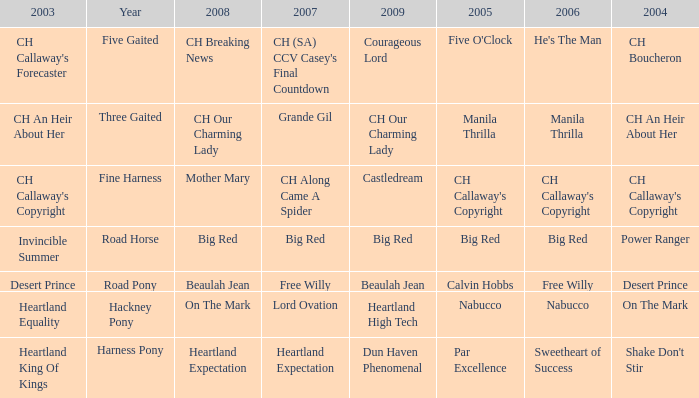What year is the 2007 big red? Road Horse. Give me the full table as a dictionary. {'header': ['2003', 'Year', '2008', '2007', '2009', '2005', '2006', '2004'], 'rows': [["CH Callaway's Forecaster", 'Five Gaited', 'CH Breaking News', "CH (SA) CCV Casey's Final Countdown", 'Courageous Lord', "Five O'Clock", "He's The Man", 'CH Boucheron'], ['CH An Heir About Her', 'Three Gaited', 'CH Our Charming Lady', 'Grande Gil', 'CH Our Charming Lady', 'Manila Thrilla', 'Manila Thrilla', 'CH An Heir About Her'], ["CH Callaway's Copyright", 'Fine Harness', 'Mother Mary', 'CH Along Came A Spider', 'Castledream', "CH Callaway's Copyright", "CH Callaway's Copyright", "CH Callaway's Copyright"], ['Invincible Summer', 'Road Horse', 'Big Red', 'Big Red', 'Big Red', 'Big Red', 'Big Red', 'Power Ranger'], ['Desert Prince', 'Road Pony', 'Beaulah Jean', 'Free Willy', 'Beaulah Jean', 'Calvin Hobbs', 'Free Willy', 'Desert Prince'], ['Heartland Equality', 'Hackney Pony', 'On The Mark', 'Lord Ovation', 'Heartland High Tech', 'Nabucco', 'Nabucco', 'On The Mark'], ['Heartland King Of Kings', 'Harness Pony', 'Heartland Expectation', 'Heartland Expectation', 'Dun Haven Phenomenal', 'Par Excellence', 'Sweetheart of Success', "Shake Don't Stir"]]} 